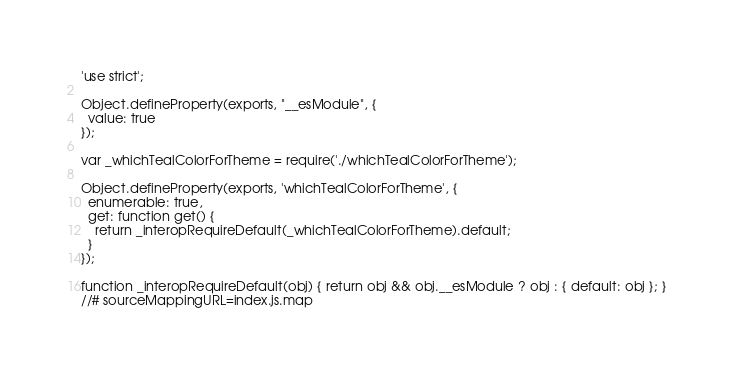Convert code to text. <code><loc_0><loc_0><loc_500><loc_500><_JavaScript_>'use strict';

Object.defineProperty(exports, "__esModule", {
  value: true
});

var _whichTealColorForTheme = require('./whichTealColorForTheme');

Object.defineProperty(exports, 'whichTealColorForTheme', {
  enumerable: true,
  get: function get() {
    return _interopRequireDefault(_whichTealColorForTheme).default;
  }
});

function _interopRequireDefault(obj) { return obj && obj.__esModule ? obj : { default: obj }; }
//# sourceMappingURL=index.js.map</code> 